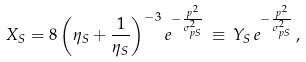Convert formula to latex. <formula><loc_0><loc_0><loc_500><loc_500>X _ { S } = 8 \left ( \eta _ { S } + \frac { 1 } { \eta _ { S } } \right ) ^ { - 3 } e ^ { - \frac { p ^ { 2 } } { \sigma _ { p S } ^ { 2 } } } \, \equiv \, Y _ { S } \, e ^ { - \frac { p ^ { 2 } } { \sigma _ { p S } ^ { 2 } } } \, ,</formula> 